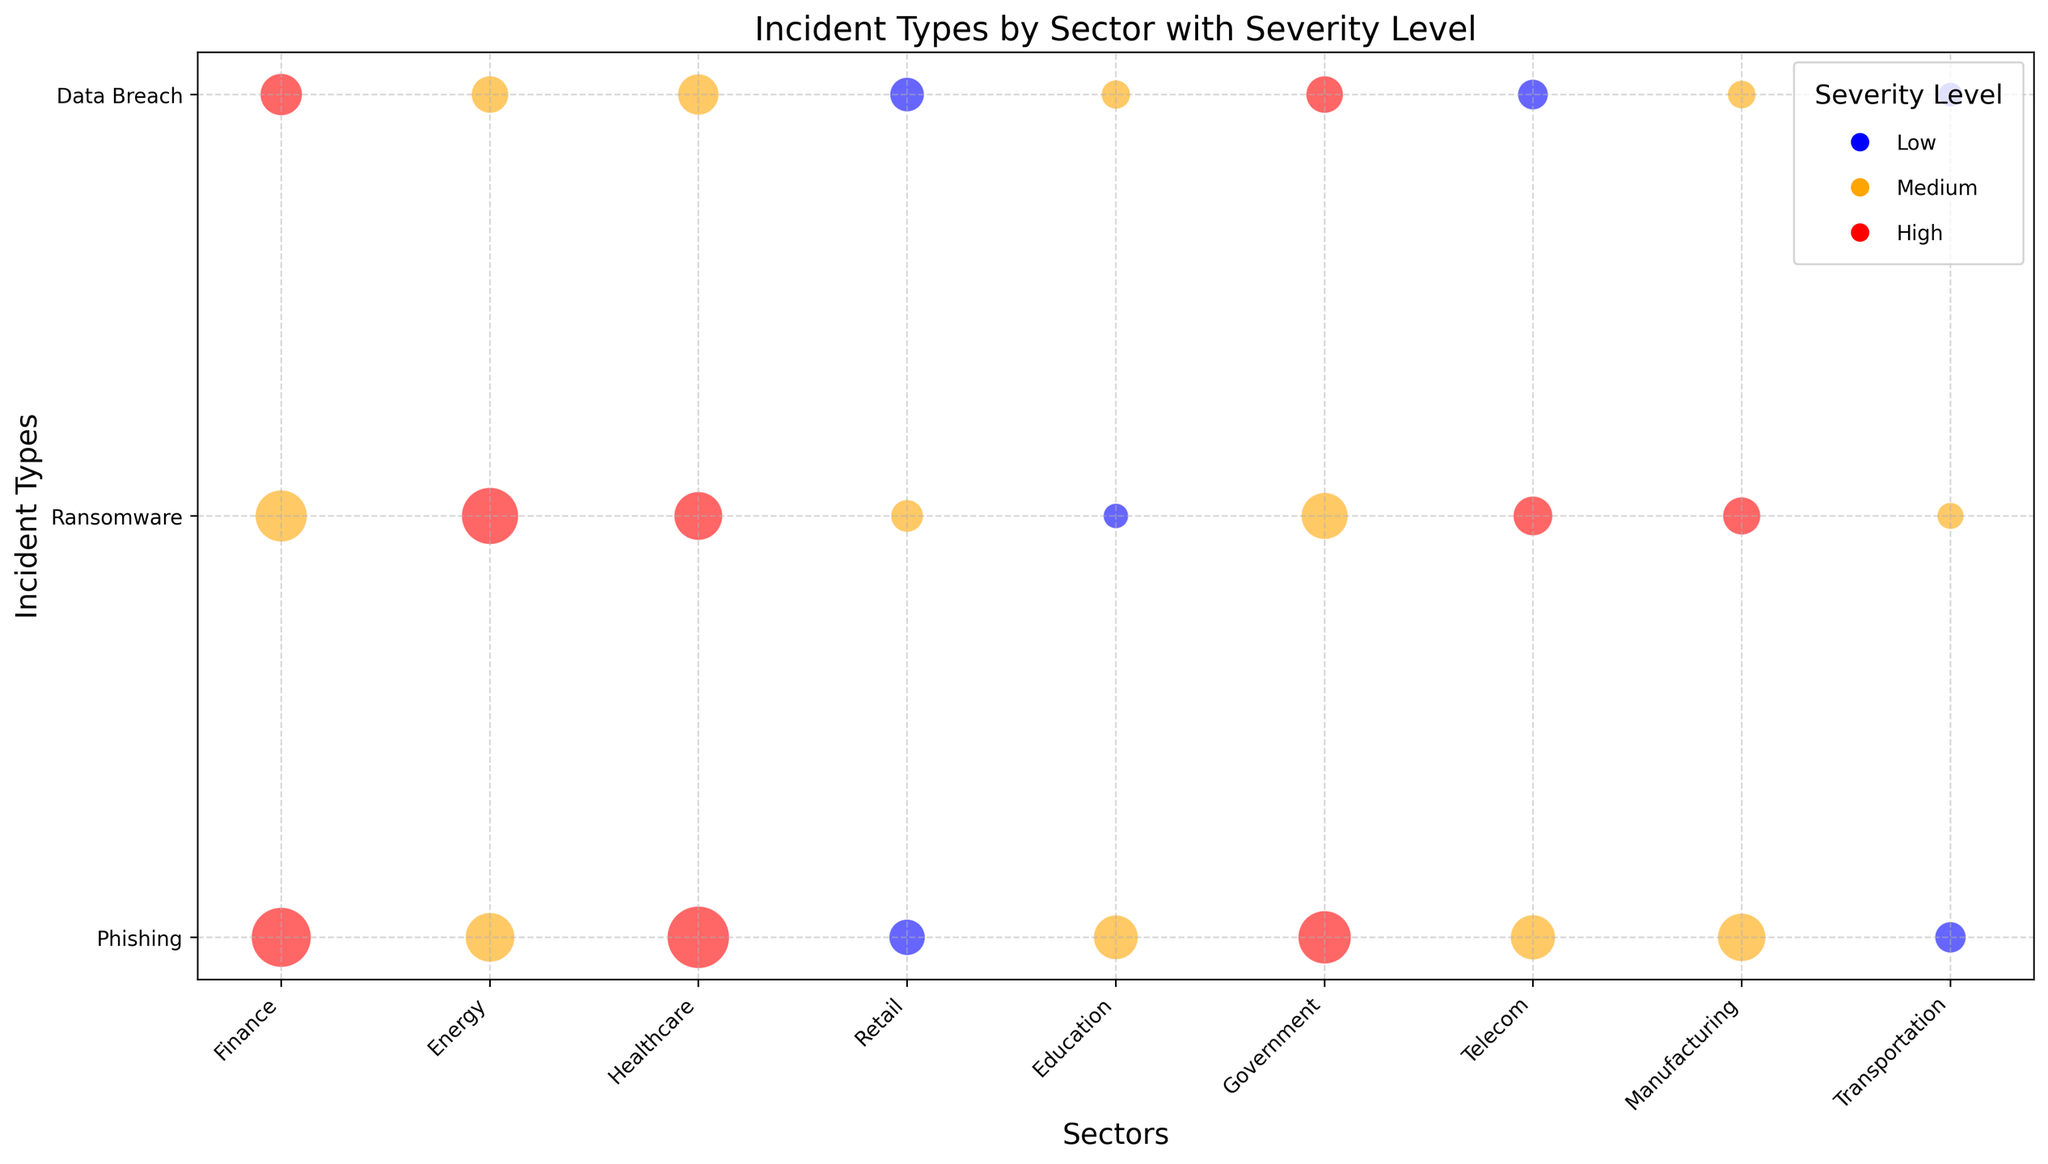What's the sector with the highest count of high severity phishing incidents? Look for the red bubbles (high severity) in the "Phishing" row and identify which sector's bubble is the largest. The sector with the largest red bubble in the phishing row is Healthcare.
Answer: Healthcare Which sector has the most incidents related to ransomware, regardless of the severity level? Identify all bubbles in the "Ransomware" row and sum up their sizes for each sector. The sector with the largest total size represents the most incidents. Finance: 64, Energy: 77, Healthcare: 56, Retail: 25, Education: 15, Government: 52, Telecom: 37, Manufacturing: 34, Transportation: 17. Energy has the highest total.
Answer: Energy What is the combined incident count for high severity incidents in the Finance sector? Sum the incident counts of the high severity (red) bubbles in the Finance sector. Finance's high severity incidents include: Phishing (85) and Data Breach (42). So, 85 + 42 = 127.
Answer: 127 Which sector has more medium severity data breach incidents, Education or Manufacturing? Compare the orange bubbles in the "Data Breach" row for Education and Manufacturing. Education's medium severity data breach count is 20, while Manufacturing's is 19. Education has more.
Answer: Education Which sector exhibits the smallest count for any incident type regardless of severity level? Identify the smallest bubble in any row (Phishing, Ransomware, Data Breach) for every sector, and find the minimum among them. The smallest bubble is in the "Transportation" sector for "Data Breach" at a low severity level, which has 14 incidents.
Answer: Transportation How many more medium severity phishing incidents are there in the Energy sector compared to the Telecom sector? Find the count of medium severity phishing incidents for Energy and Telecom sectors and compute their difference. Energy has 58 and Telecom has 48 medium severity phishing incidents. So, 58 - 48 = 10.
Answer: 10 Which sector has a single largest bubble regardless of severity or incident type? Identify the largest bubble by visually comparing the sizes across all rows and sectors. The largest bubble is in the Healthcare sector for the "Phishing" incident type with a count of 92.
Answer: Healthcare How many total high severity incidents are reported in the Government sector? Sum the incident counts of high severity (red) bubbles in the Government sector. Government's high severity incidents include: Phishing (67) and Data Breach (33). So, 67 + 33 = 100.
Answer: 100 